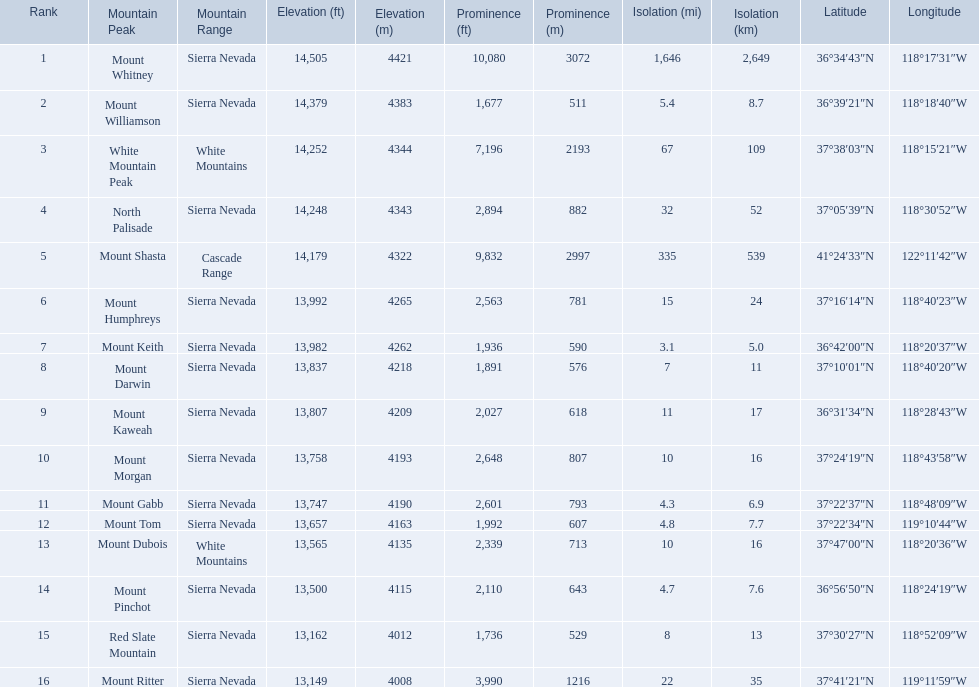Which mountain peak is in the white mountains range? White Mountain Peak. Which mountain is in the sierra nevada range? Mount Whitney. Which mountain is the only one in the cascade range? Mount Shasta. 